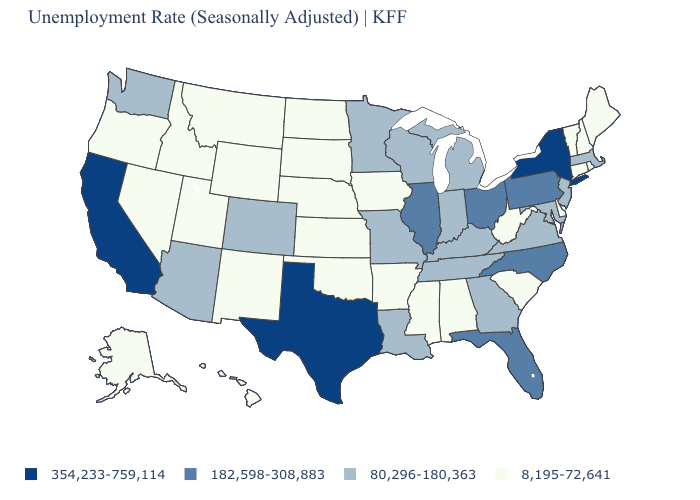Does New York have the highest value in the Northeast?
Short answer required. Yes. Which states have the lowest value in the West?
Short answer required. Alaska, Hawaii, Idaho, Montana, Nevada, New Mexico, Oregon, Utah, Wyoming. Is the legend a continuous bar?
Give a very brief answer. No. Name the states that have a value in the range 182,598-308,883?
Short answer required. Florida, Illinois, North Carolina, Ohio, Pennsylvania. Among the states that border Illinois , which have the highest value?
Concise answer only. Indiana, Kentucky, Missouri, Wisconsin. What is the value of Kansas?
Give a very brief answer. 8,195-72,641. Name the states that have a value in the range 8,195-72,641?
Short answer required. Alabama, Alaska, Arkansas, Connecticut, Delaware, Hawaii, Idaho, Iowa, Kansas, Maine, Mississippi, Montana, Nebraska, Nevada, New Hampshire, New Mexico, North Dakota, Oklahoma, Oregon, Rhode Island, South Carolina, South Dakota, Utah, Vermont, West Virginia, Wyoming. Does Colorado have a lower value than New Mexico?
Keep it brief. No. What is the value of Wyoming?
Give a very brief answer. 8,195-72,641. Does Texas have the lowest value in the USA?
Answer briefly. No. What is the lowest value in the South?
Quick response, please. 8,195-72,641. Name the states that have a value in the range 80,296-180,363?
Short answer required. Arizona, Colorado, Georgia, Indiana, Kentucky, Louisiana, Maryland, Massachusetts, Michigan, Minnesota, Missouri, New Jersey, Tennessee, Virginia, Washington, Wisconsin. What is the value of Indiana?
Short answer required. 80,296-180,363. Name the states that have a value in the range 354,233-759,114?
Quick response, please. California, New York, Texas. 